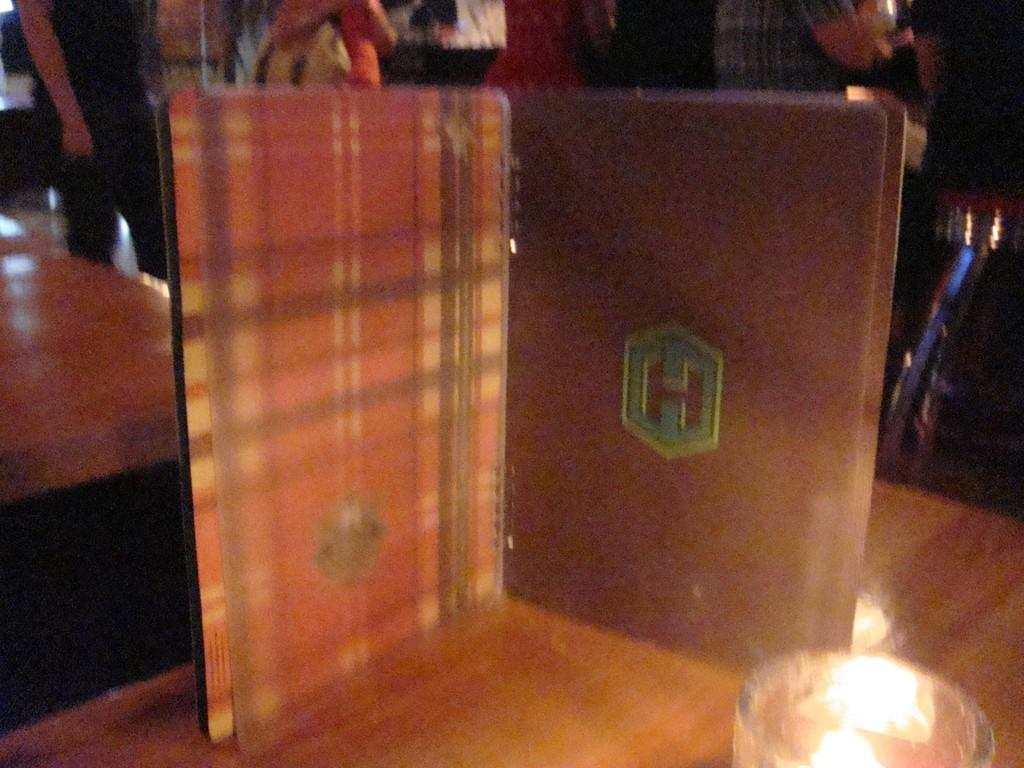What is the main piece of furniture in the image? There is a table in the image. What is placed on the table? There is a board and a glass on the table. Are there any other objects or people visible in the image? Yes, there are other people standing behind the table. What type of berry can be seen in the glass on the table? There is no berry visible in the glass on the table; it is empty. 